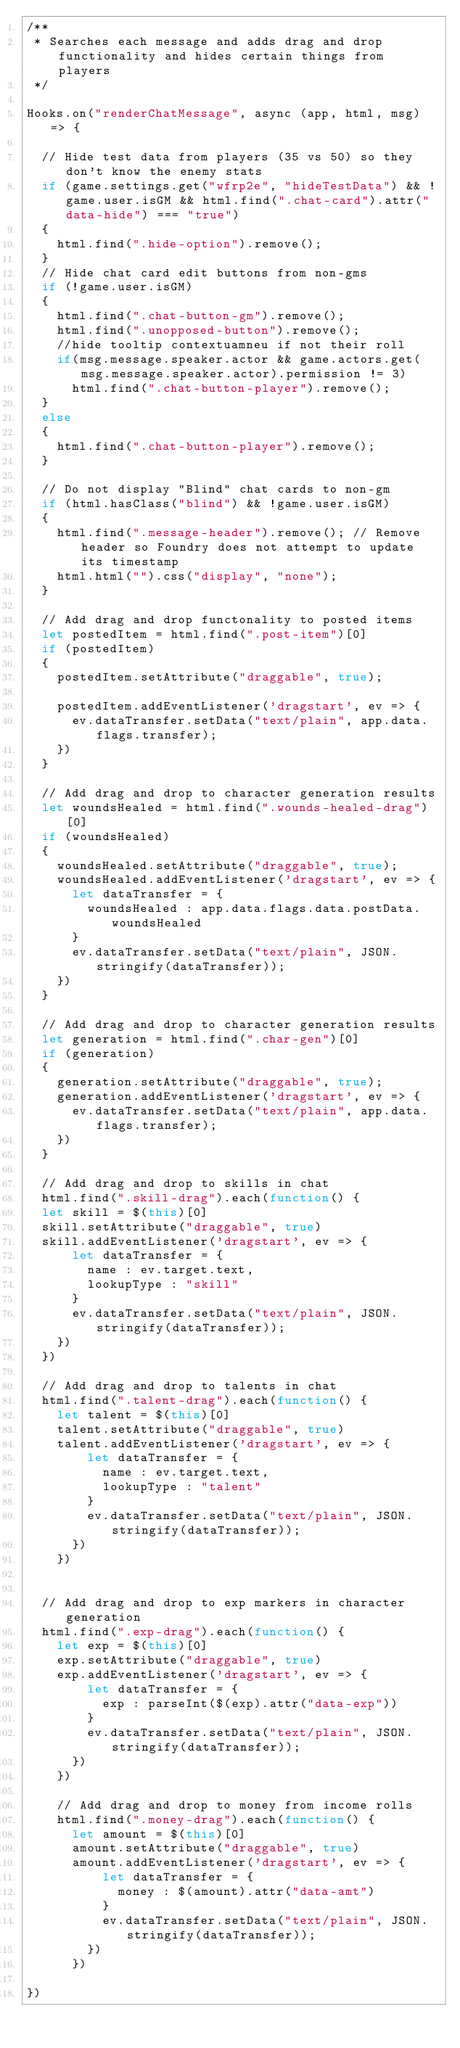<code> <loc_0><loc_0><loc_500><loc_500><_JavaScript_>/**
 * Searches each message and adds drag and drop functionality and hides certain things from players
 */

Hooks.on("renderChatMessage", async (app, html, msg) => {
  
  // Hide test data from players (35 vs 50) so they don't know the enemy stats
  if (game.settings.get("wfrp2e", "hideTestData") && !game.user.isGM && html.find(".chat-card").attr("data-hide") === "true")
  {
    html.find(".hide-option").remove();
  }
  // Hide chat card edit buttons from non-gms
  if (!game.user.isGM)
  {
    html.find(".chat-button-gm").remove();
    html.find(".unopposed-button").remove();
    //hide tooltip contextuamneu if not their roll
    if(msg.message.speaker.actor && game.actors.get(msg.message.speaker.actor).permission != 3)
      html.find(".chat-button-player").remove();
  }
  else
  {
    html.find(".chat-button-player").remove();
  }

  // Do not display "Blind" chat cards to non-gm
  if (html.hasClass("blind") && !game.user.isGM)
  {
    html.find(".message-header").remove(); // Remove header so Foundry does not attempt to update its timestamp
    html.html("").css("display", "none");
  }

  // Add drag and drop functonality to posted items
  let postedItem = html.find(".post-item")[0]
  if (postedItem)
  {
    postedItem.setAttribute("draggable", true);

    postedItem.addEventListener('dragstart', ev => {
      ev.dataTransfer.setData("text/plain", app.data.flags.transfer);
    })
  }

  // Add drag and drop to character generation results
  let woundsHealed = html.find(".wounds-healed-drag")[0]
  if (woundsHealed)
  {
    woundsHealed.setAttribute("draggable", true);
    woundsHealed.addEventListener('dragstart', ev => {
      let dataTransfer = {
        woundsHealed : app.data.flags.data.postData.woundsHealed
      }
      ev.dataTransfer.setData("text/plain", JSON.stringify(dataTransfer));
    })
  }

  // Add drag and drop to character generation results
  let generation = html.find(".char-gen")[0]
  if (generation)
  {
    generation.setAttribute("draggable", true);
    generation.addEventListener('dragstart', ev => {
      ev.dataTransfer.setData("text/plain", app.data.flags.transfer);
    })
  }

  // Add drag and drop to skills in chat
  html.find(".skill-drag").each(function() {
  let skill = $(this)[0]
  skill.setAttribute("draggable", true)
  skill.addEventListener('dragstart', ev => {
      let dataTransfer = {
        name : ev.target.text,
        lookupType : "skill"
      }
      ev.dataTransfer.setData("text/plain", JSON.stringify(dataTransfer));
    })
  })

  // Add drag and drop to talents in chat
  html.find(".talent-drag").each(function() {
    let talent = $(this)[0]
    talent.setAttribute("draggable", true)
    talent.addEventListener('dragstart', ev => {
        let dataTransfer = {
          name : ev.target.text,
          lookupType : "talent"
        }
        ev.dataTransfer.setData("text/plain", JSON.stringify(dataTransfer));
      })
    })


  // Add drag and drop to exp markers in character generation
  html.find(".exp-drag").each(function() {
    let exp = $(this)[0]
    exp.setAttribute("draggable", true)
    exp.addEventListener('dragstart', ev => {
        let dataTransfer = {
          exp : parseInt($(exp).attr("data-exp"))
        }
        ev.dataTransfer.setData("text/plain", JSON.stringify(dataTransfer));
      })
    })

    // Add drag and drop to money from income rolls
    html.find(".money-drag").each(function() {
      let amount = $(this)[0]
      amount.setAttribute("draggable", true)
      amount.addEventListener('dragstart', ev => {
          let dataTransfer = {
            money : $(amount).attr("data-amt")
          }
          ev.dataTransfer.setData("text/plain", JSON.stringify(dataTransfer));
        })
      })

})</code> 